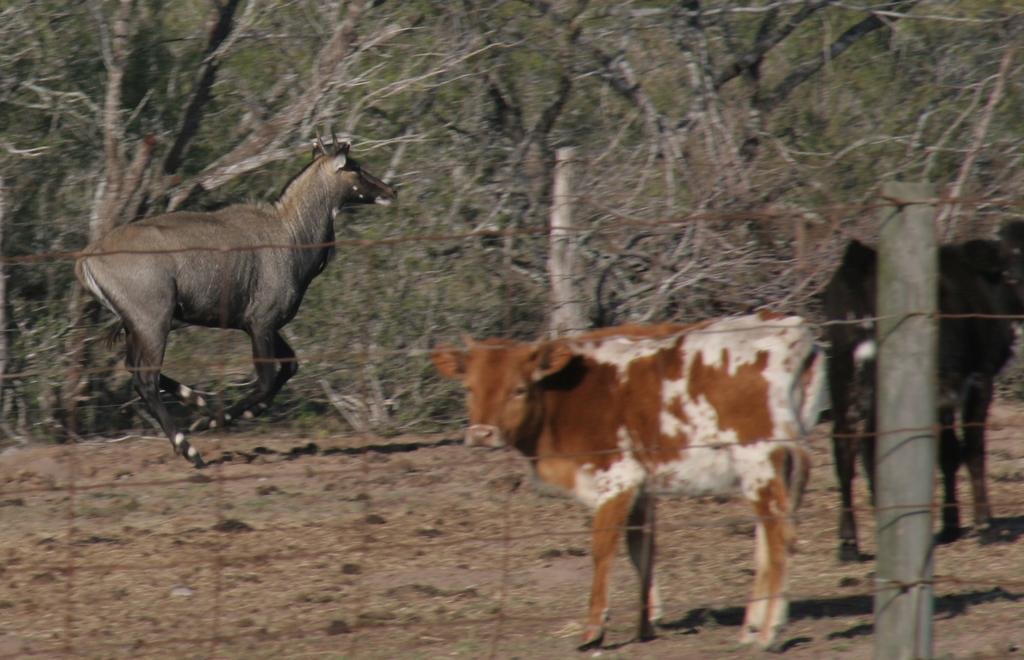What animal is in the foreground of the image? There is a cow in the foreground of the image. What can be seen behind the fencing in the image? There are two animals behind the fencing. What type of vegetation is visible in the background of the image? There are trees in the background of the image. What type of beds are visible in the image? There are no beds present in the image. What type of meat is being prepared by the cow in the image? The cow is not preparing any meat in the image; it is simply standing in the foreground. 